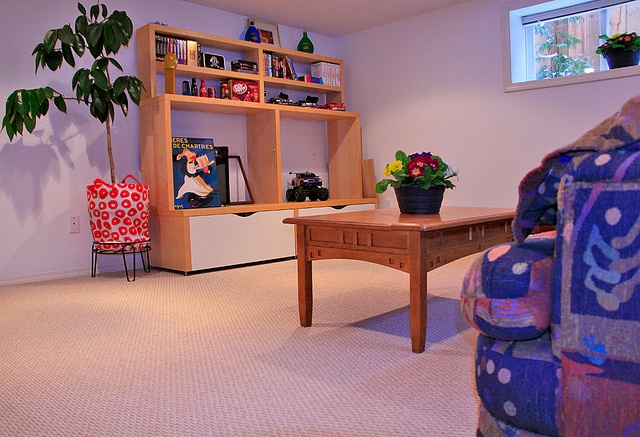Describe the objects in this image and their specific colors. I can see couch in gray, navy, and purple tones, potted plant in gray, black, darkgray, and red tones, potted plant in gray, black, lightpink, darkgreen, and maroon tones, potted plant in gray, black, navy, darkgreen, and darkblue tones, and truck in gray, black, and maroon tones in this image. 